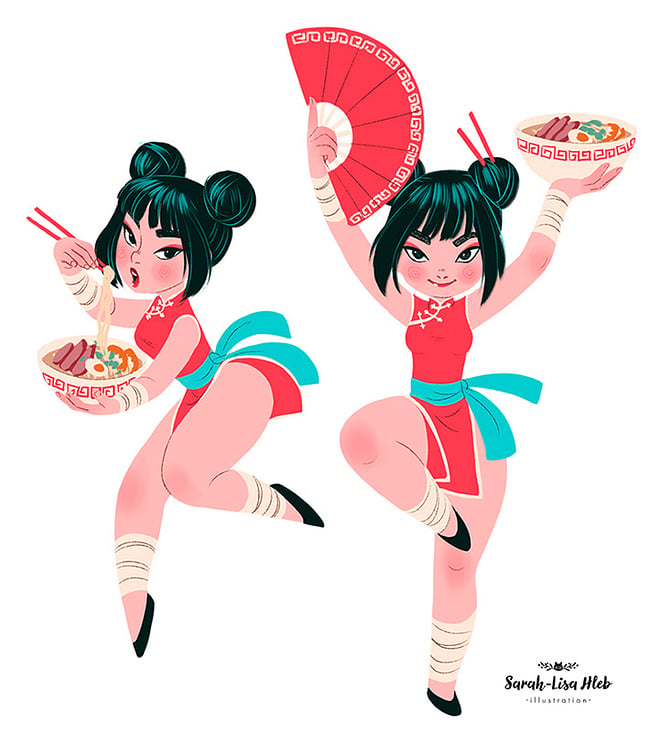Considering the props being held by the characters, what cultural significance could these items have, and how do they contribute to the narrative of the image? The props, a bowl of noodles and a folded fan, are deeply emblematic of traditional Asian cultures. Noodles are often associated with longevity and health in many Asian traditions, and enjoying them as depicted in the image suggests a celebration of life and cultural heritage. The fan, historically used in various Asian dances and ceremonies, adds an element of grace and artistry, reinforcing the cultural depth. Together, these props not only accentuate the cultural homage but also enrich the narrative by embedding traditional symbols of heritage and celebration into a dynamic, modern portrayal. 